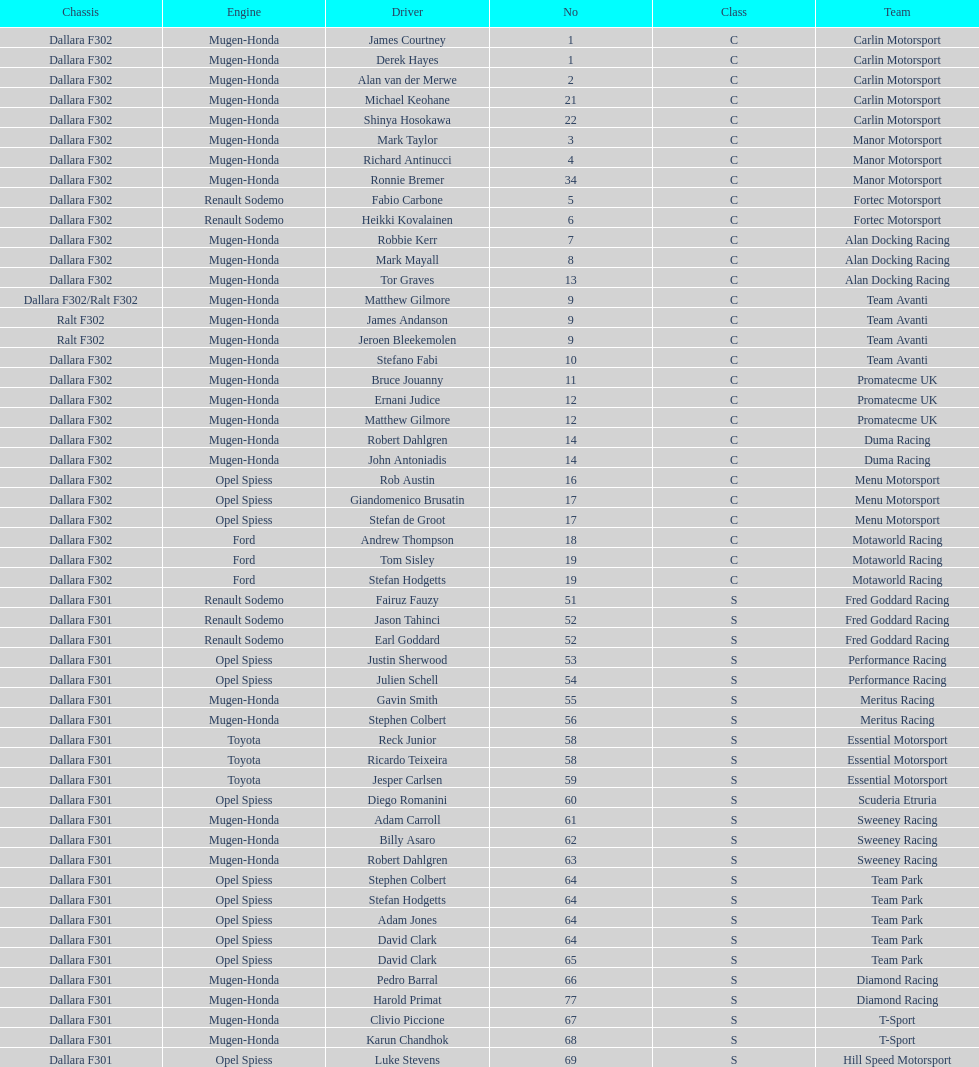What is the average number of teams that had a mugen-honda engine? 24. 